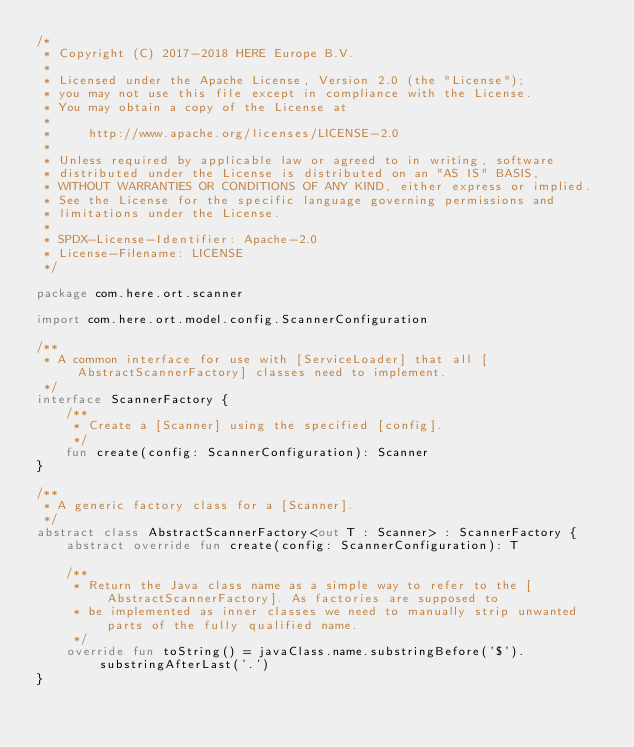<code> <loc_0><loc_0><loc_500><loc_500><_Kotlin_>/*
 * Copyright (C) 2017-2018 HERE Europe B.V.
 *
 * Licensed under the Apache License, Version 2.0 (the "License");
 * you may not use this file except in compliance with the License.
 * You may obtain a copy of the License at
 *
 *     http://www.apache.org/licenses/LICENSE-2.0
 *
 * Unless required by applicable law or agreed to in writing, software
 * distributed under the License is distributed on an "AS IS" BASIS,
 * WITHOUT WARRANTIES OR CONDITIONS OF ANY KIND, either express or implied.
 * See the License for the specific language governing permissions and
 * limitations under the License.
 *
 * SPDX-License-Identifier: Apache-2.0
 * License-Filename: LICENSE
 */

package com.here.ort.scanner

import com.here.ort.model.config.ScannerConfiguration

/**
 * A common interface for use with [ServiceLoader] that all [AbstractScannerFactory] classes need to implement.
 */
interface ScannerFactory {
    /**
     * Create a [Scanner] using the specified [config].
     */
    fun create(config: ScannerConfiguration): Scanner
}

/**
 * A generic factory class for a [Scanner].
 */
abstract class AbstractScannerFactory<out T : Scanner> : ScannerFactory {
    abstract override fun create(config: ScannerConfiguration): T

    /**
     * Return the Java class name as a simple way to refer to the [AbstractScannerFactory]. As factories are supposed to
     * be implemented as inner classes we need to manually strip unwanted parts of the fully qualified name.
     */
    override fun toString() = javaClass.name.substringBefore('$').substringAfterLast('.')
}
</code> 